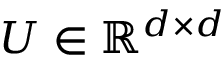Convert formula to latex. <formula><loc_0><loc_0><loc_500><loc_500>U \in \mathbb { R } ^ { d \times d }</formula> 